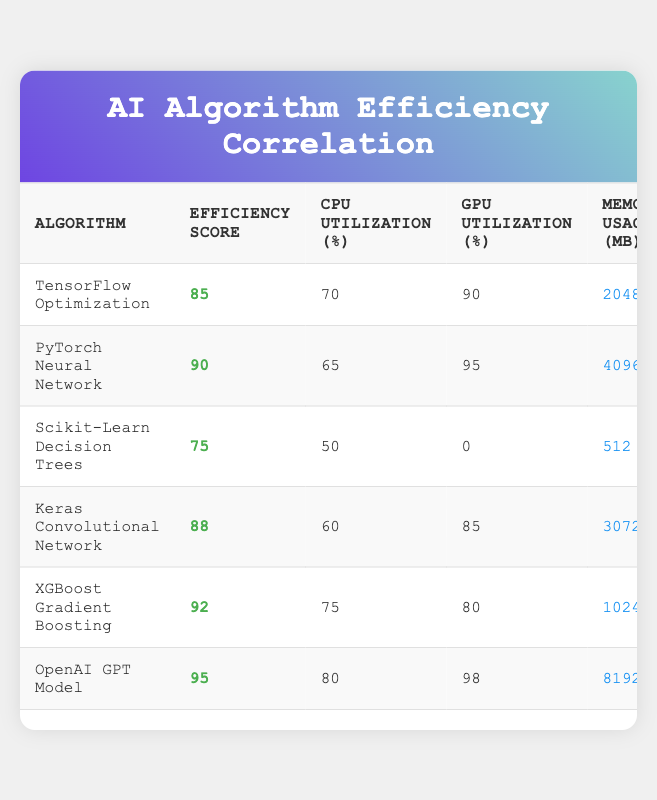What is the efficiency score of the Keras Convolutional Network? The efficiency score for the Keras Convolutional Network is listed directly in the table under the "Efficiency Score" column, which shows 88.
Answer: 88 Which algorithm has the highest GPU utilization percentage? The OpenAI GPT Model has the highest GPU utilization percentage, as its value is 98, which is higher than all other algorithms listed in the table.
Answer: OpenAI GPT Model Which algorithm has the lowest execution time? By comparing the values in the "Execution Time" column, Scikit-Learn Decision Trees has the lowest time at 30 seconds, lower than any other algorithm.
Answer: Scikit-Learn Decision Trees What is the average memory usage of all algorithms? Adding up the memory usage values (2048 + 4096 + 512 + 3072 + 1024 + 8192) gives 18,944 MB. Dividing this total by the number of algorithms (6) yields an average of 3140.67 MB.
Answer: 3140.67 Is the efficiency score of the XGBoost Gradient Boosting algorithm greater than 90? The efficiency score of XGBoost Gradient Boosting is 92, which is indeed greater than 90.
Answer: Yes Which algorithm has the highest efficiency score, and what is the difference in efficiency score between this algorithm and the TensorFlow Optimization algorithm? The OpenAI GPT Model has the highest efficiency score at 95. The efficiency score of TensorFlow Optimization is 85. The difference is calculated by subtracting 85 from 95, resulting in 10.
Answer: 10 What is the total CPU utilization percentage of all algorithms combined? Summing the CPU utilization percentages (70 + 65 + 50 + 60 + 75 + 80) gives a total of 400 percent.
Answer: 400 Does PyTorch Neural Network have higher efficiency compared to Keras Convolutional Network? The efficiency score for PyTorch Neural Network is 90, while Keras Convolutional Network has an efficiency score of 88, indicating that PyTorch is more efficient.
Answer: Yes How does the memory usage of the OpenAI GPT Model compare to the average memory usage of the algorithms listed? The memory usage for the OpenAI GPT Model is 8192 MB. We previously calculated the average memory usage as 3140.67 MB. Since 8192 is greater than 3140.67, it indicates that OpenAI GPT Model uses significantly more memory than the average.
Answer: Greater 